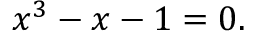Convert formula to latex. <formula><loc_0><loc_0><loc_500><loc_500>x ^ { 3 } - x - 1 = 0 .</formula> 